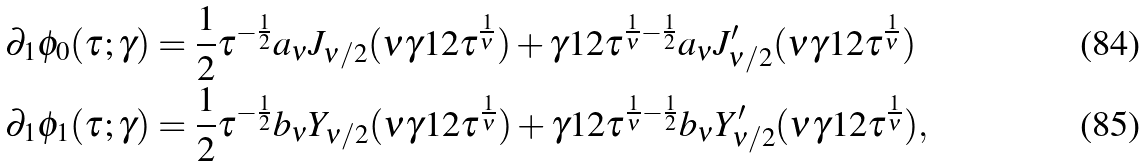Convert formula to latex. <formula><loc_0><loc_0><loc_500><loc_500>\partial _ { 1 } \phi _ { 0 } ( \tau ; \gamma ) & = \frac { 1 } { 2 } \tau ^ { - \frac { 1 } { 2 } } a _ { \nu } J _ { \nu / 2 } ( \nu \gamma ^ { } { 1 } 2 \tau ^ { \frac { 1 } { \nu } } ) + \gamma ^ { } { 1 } 2 \tau ^ { \frac { 1 } { \nu } - \frac { 1 } { 2 } } a _ { \nu } J ^ { \prime } _ { \nu / 2 } ( \nu \gamma ^ { } { 1 } 2 \tau ^ { \frac { 1 } { \nu } } ) \\ \partial _ { 1 } \phi _ { 1 } ( \tau ; \gamma ) & = \frac { 1 } { 2 } \tau ^ { - \frac { 1 } { 2 } } b _ { \nu } Y _ { \nu / 2 } ( \nu \gamma ^ { } { 1 } 2 \tau ^ { \frac { 1 } { \nu } } ) + \gamma ^ { } { 1 } 2 \tau ^ { \frac { 1 } { \nu } - \frac { 1 } { 2 } } b _ { \nu } Y ^ { \prime } _ { \nu / 2 } ( \nu \gamma ^ { } { 1 } 2 \tau ^ { \frac { 1 } { \nu } } ) ,</formula> 